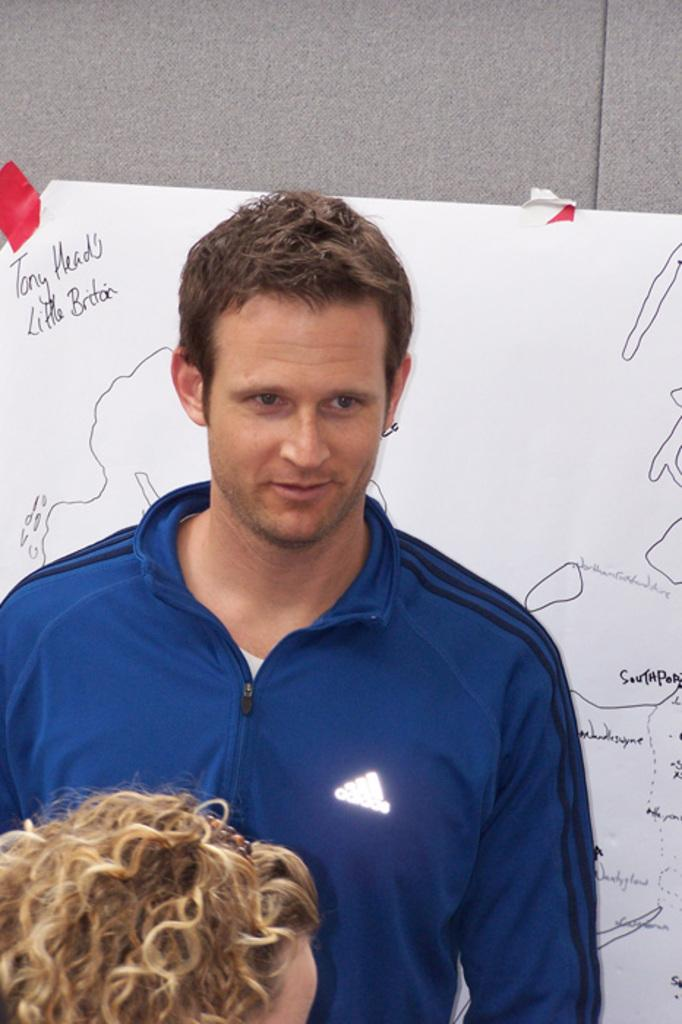Who is present in the image? There is a man and a woman in the image. What is the man wearing in the image? The man is wearing a blue jacket in the image. What is the man doing in the image? The man is standing near a board in the image. What is the woman wearing in the image? The woman is wearing a hairband in the image. What can be seen in the background of the image? There is a wall visible in the image. What type of cap is the man wearing in the image? The man is not wearing a cap in the image; he is wearing a blue jacket. Is the image taken during winter? The provided facts do not mention the season or weather, so it cannot be determined if the image was taken during winter. 